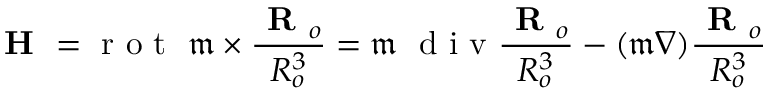Convert formula to latex. <formula><loc_0><loc_0><loc_500><loc_500>H = r o t \ \mathfrak { m } \times \frac { R _ { o } } { R _ { o } ^ { 3 } } = \mathfrak { m } \ d i v \frac { R _ { o } } { R _ { o } ^ { 3 } } - ( \mathfrak { m } \nabla ) \frac { R _ { o } } { R _ { o } ^ { 3 } }</formula> 